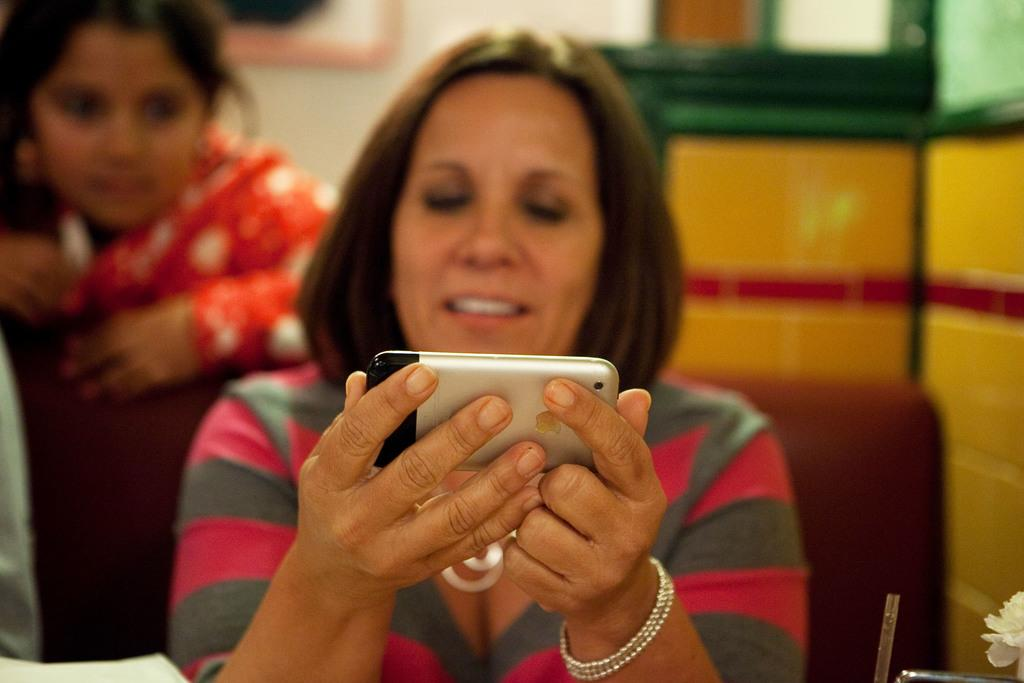What is the woman in the image wearing? The woman is wearing a t-shirt. What is the woman's facial expression in the image? The woman is smiling. What is the woman doing in the image? The woman is watching a mobile. What is the woman's position in the image? The woman is sitting on a chair. Can you describe the background of the image? There is another woman in the background of the image, and there is a wall. What is the second woman doing in the image? The second woman is also watching a mobile. What type of holiday is the woman celebrating in the image? There is no indication of a holiday in the image; it simply shows a woman watching a mobile while sitting on a chair. 